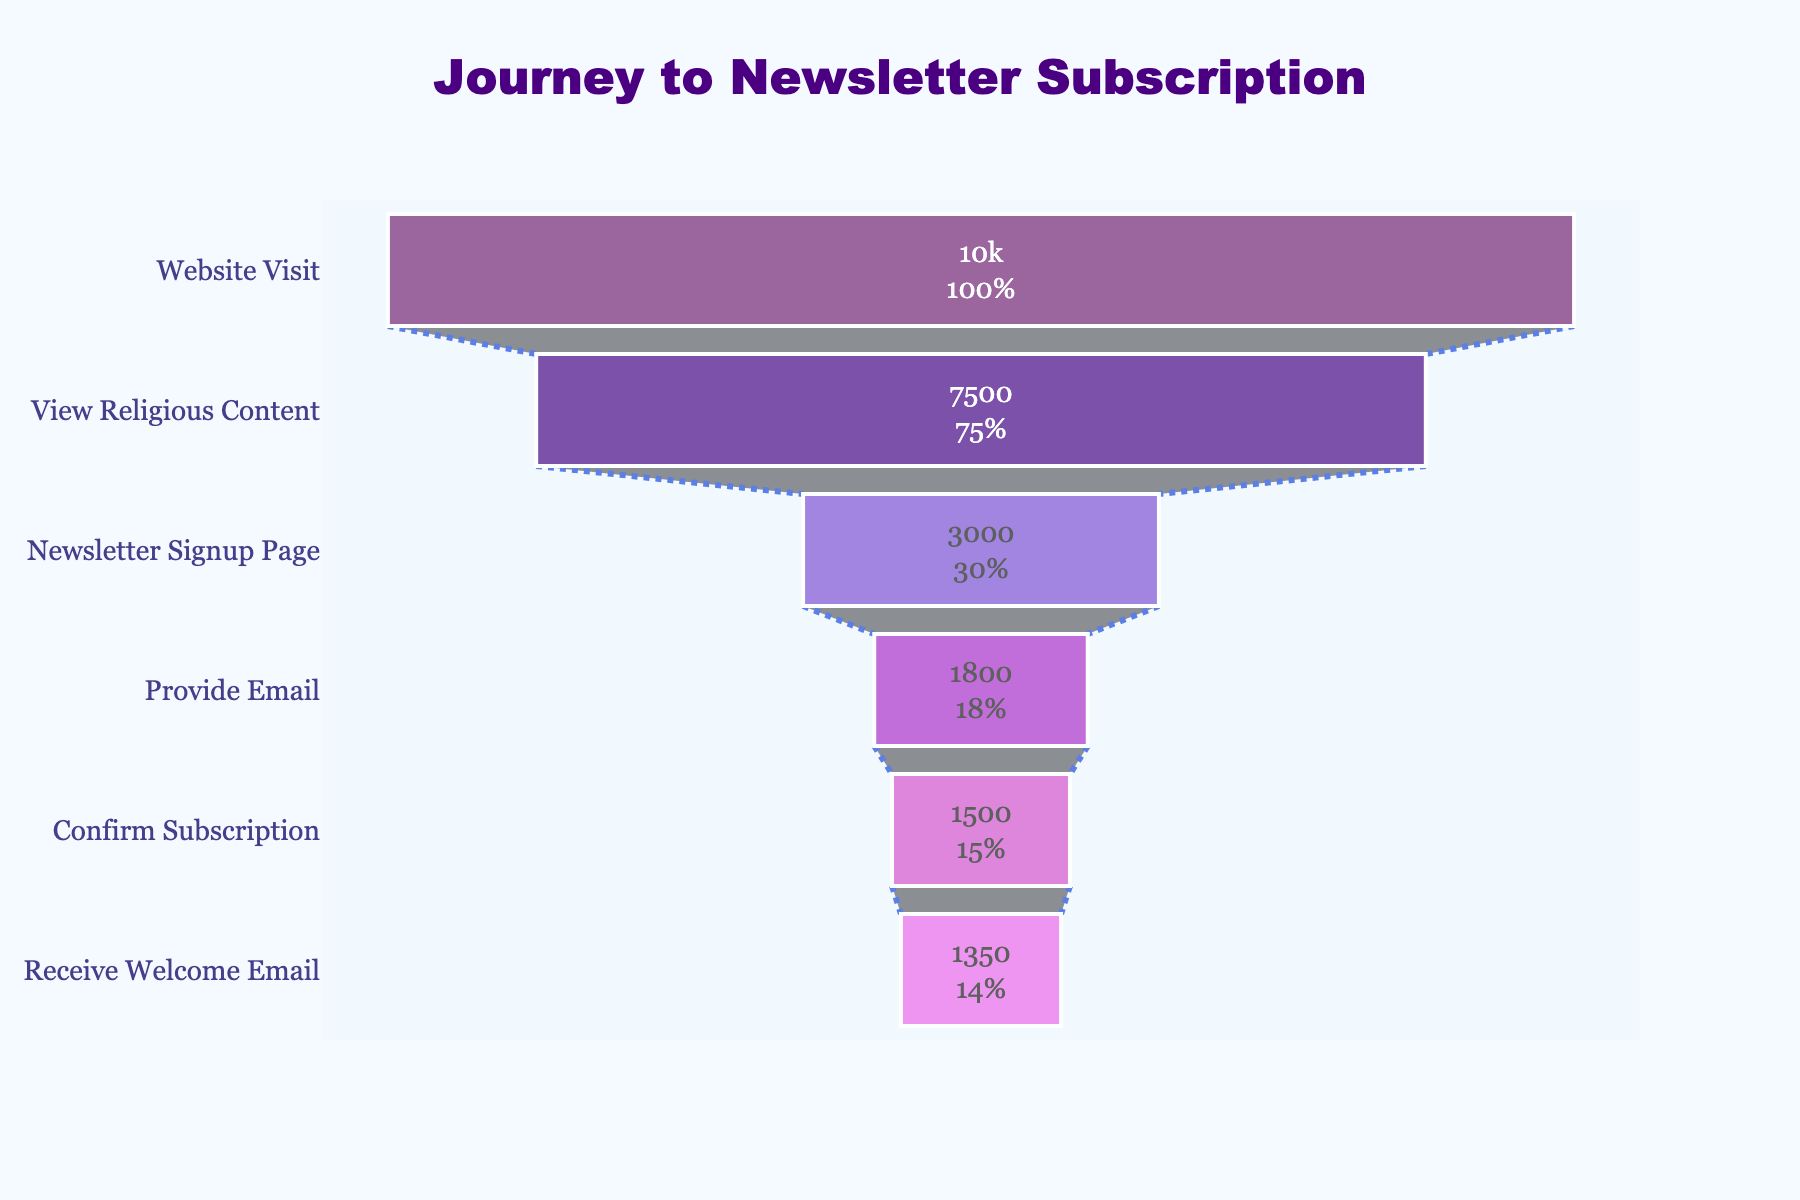What is the title of the funnel chart? The title is found at the top center of the chart and indicates the main purpose of the visual.
Answer: Journey to Newsletter Subscription What percentage of visitors view religious content relative to the initial number of visitors? First, locate the number of initial visitors (10,000) and the number of visitors who view religious content (7,500). Then, calculate the percentage: (7,500 / 10,000) * 100.
Answer: 75% How many visitors do not proceed from the Newsletter Signup Page to providing their email? Identify the number of visitors who make it to the Newsletter Signup Page (3,000) and the number who provide their email (1,800). Subtract the latter from the former: 3,000 - 1,800.
Answer: 1,200 What is the color of the section representing 'Confirm Subscription'? Look at the color coding in the chart. The 'Confirm Subscription' stage is marked by a specific color that is distinctly observable.
Answer: Violet (EE82EE) How does the number of visitors who confirm their subscription compare to those who receive the welcome email? Identify the number of visitors at the 'Confirm Subscription' stage (1,500) and those at the 'Receive Welcome Email' stage (1,350). Since 1,500 > 1,350, the former is greater.
Answer: Confirm Subscription is greater Which stage has the largest drop in the number of visitors and how many visitors are lost in that stage? Calculate the differences in visitor numbers between consecutive stages: Website Visit (10,000) to View Religious Content (7,500) = 2,500; View Religious Content (7,500) to Newsletter Signup Page (3,000) = 4,500; Newsletter Signup Page (3,000) to Provide Email (1,800) = 1,200; Provide Email (1,800) to Confirm Subscription (1,500) = 300; Confirm Subscription (1,500) to Receive Welcome Email (1,350) = 150. The largest drop is between viewing religious content and the newsletter signup page, with a loss of 4,500 visitors.
Answer: View Religious Content to Newsletter Signup Page, 4,500 visitors What percentage of visitors from the 'Provide Email' stage confirm their subscription? Find the number of visitors who provide email (1,800) and those who confirm their subscription (1,500). The percentage is calculated as (1,500/1,800) * 100.
Answer: 83.33% What is the text position and informational detail provided within the funnel sections? Each section of the funnel chart contains text that provides specific information like values and percentages related to the initial number of visitors. These texts are positioned inside the sections.
Answer: Inside, value+percent initial 